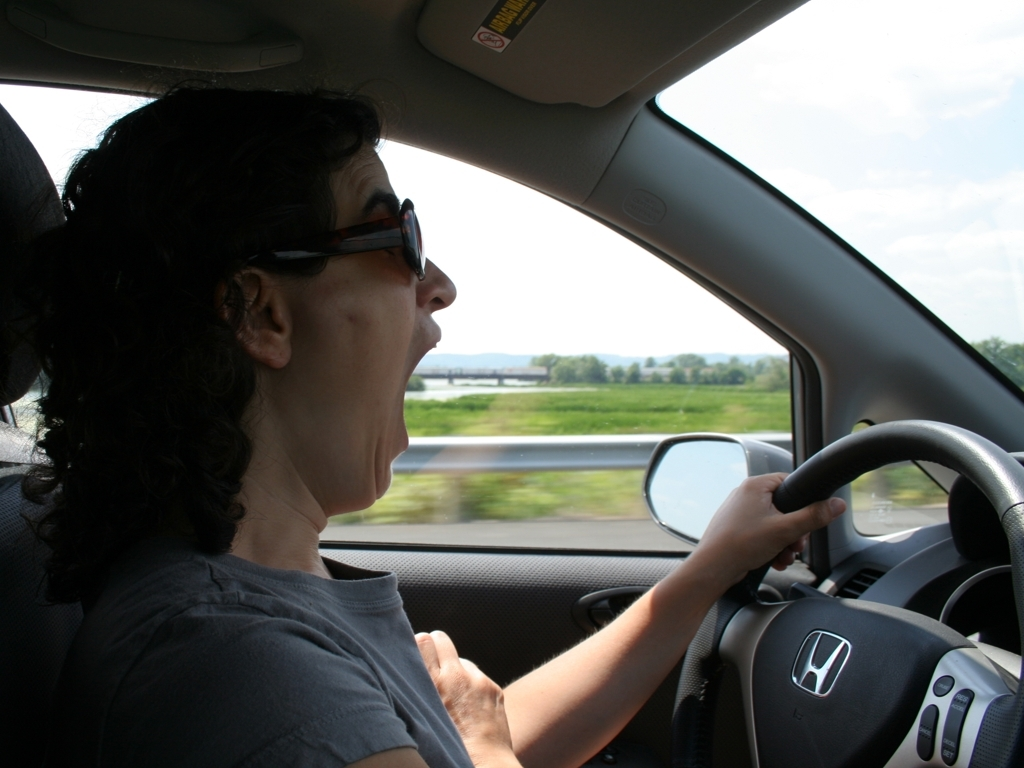Does the image give any indication of the speed at which the vehicle is traveling? While it's difficult to determine the exact speed, the motion blur of the scenery outside and the driver's focused expression might imply that the vehicle is moving at a moderate to fast pace. What safety elements can we observe from the driver's behavior? The driver is wearing a seatbelt, as can be seen from the diagonal strap across her chest, indicating adherence to safety regulations. Additionally, her hands are properly positioned on the steering wheel, which suggests that she is attentively driving. 